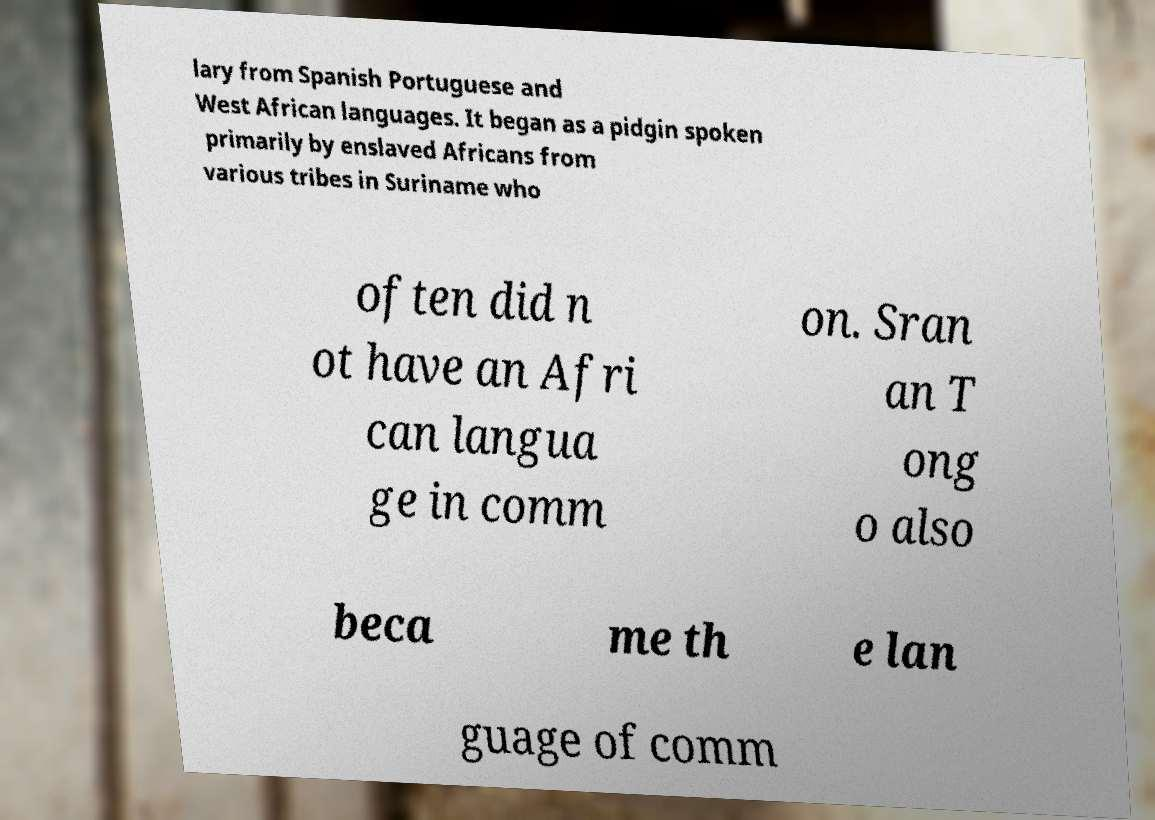Please identify and transcribe the text found in this image. lary from Spanish Portuguese and West African languages. It began as a pidgin spoken primarily by enslaved Africans from various tribes in Suriname who often did n ot have an Afri can langua ge in comm on. Sran an T ong o also beca me th e lan guage of comm 